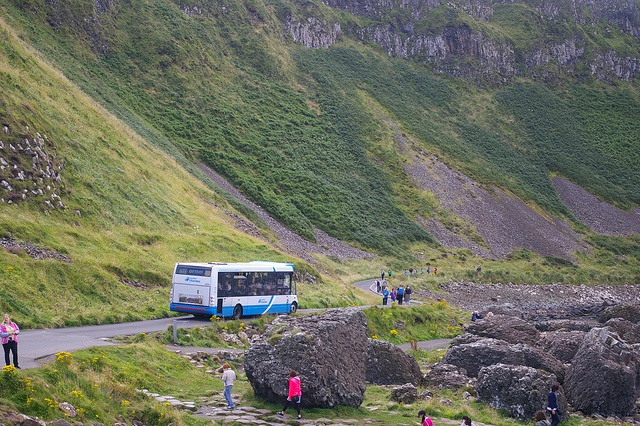Describe the objects in this image and their specific colors. I can see bus in darkgreen, lavender, navy, and gray tones, people in darkgreen, tan, darkgray, gray, and black tones, people in darkgreen, black, gray, and navy tones, people in darkgreen, black, pink, magenta, and violet tones, and people in darkgreen, black, brown, magenta, and maroon tones in this image. 